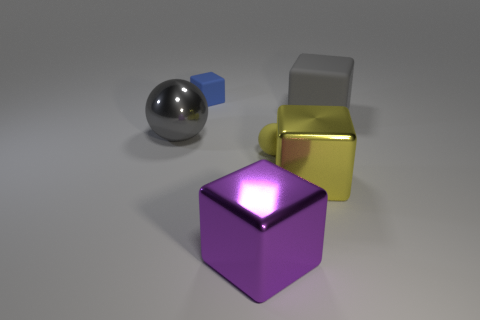Add 4 yellow shiny objects. How many objects exist? 10 Subtract all blocks. How many objects are left? 2 Subtract all gray matte cylinders. Subtract all big yellow things. How many objects are left? 5 Add 5 yellow matte things. How many yellow matte things are left? 6 Add 5 big gray blocks. How many big gray blocks exist? 6 Subtract 0 red cylinders. How many objects are left? 6 